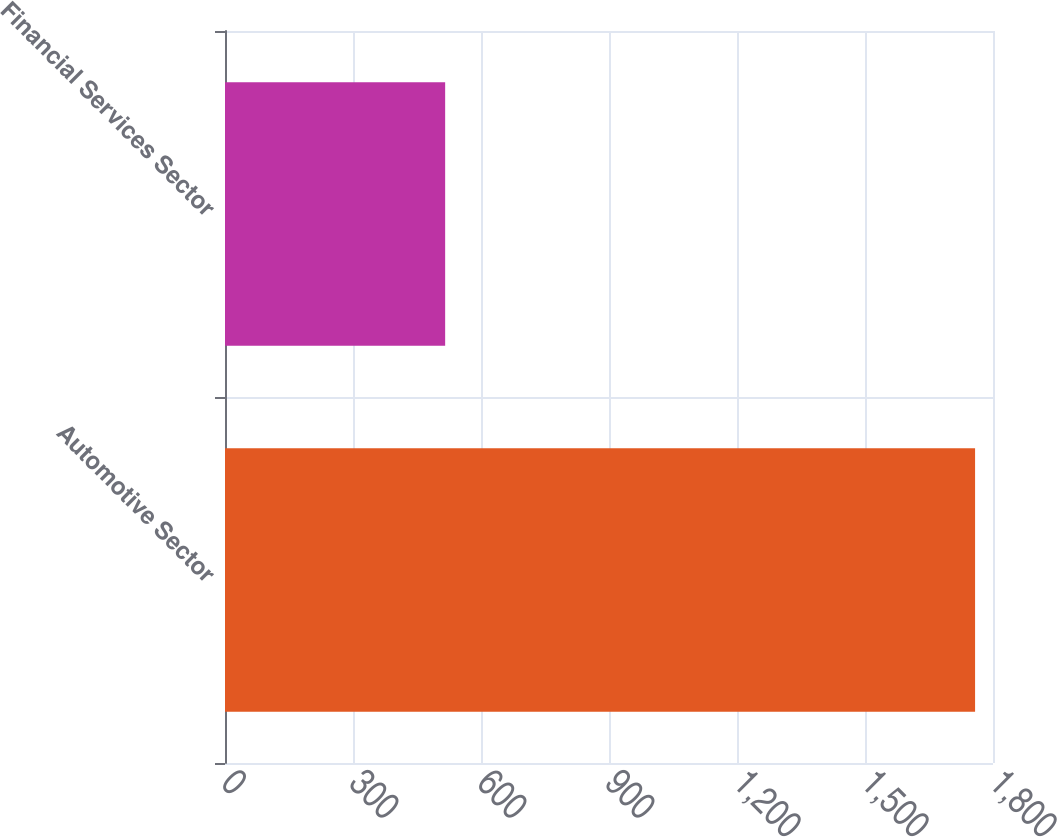Convert chart to OTSL. <chart><loc_0><loc_0><loc_500><loc_500><bar_chart><fcel>Automotive Sector<fcel>Financial Services Sector<nl><fcel>1758<fcel>516<nl></chart> 